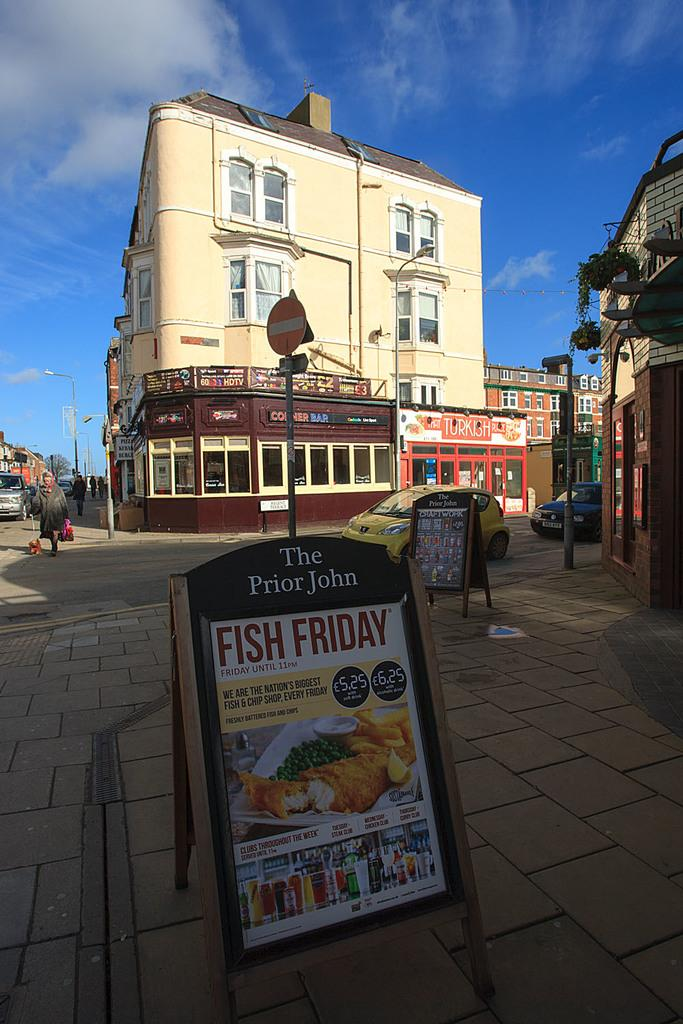Where was the image taken? The image was clicked outside. What can be seen in the middle of the image? There are buildings in the middle of the image. What is visible at the top of the image? There is sky visible at the top of the image. What type of vehicle is present in the image? There is a car on the left side and middle of the image. Can you identify any people in the image? Yes, there is a person on the left side of the image. Is there a volcano erupting in the background of the image? No, there is no volcano present in the image. What type of wall can be seen surrounding the buildings in the image? There is no wall surrounding the buildings in the image. 